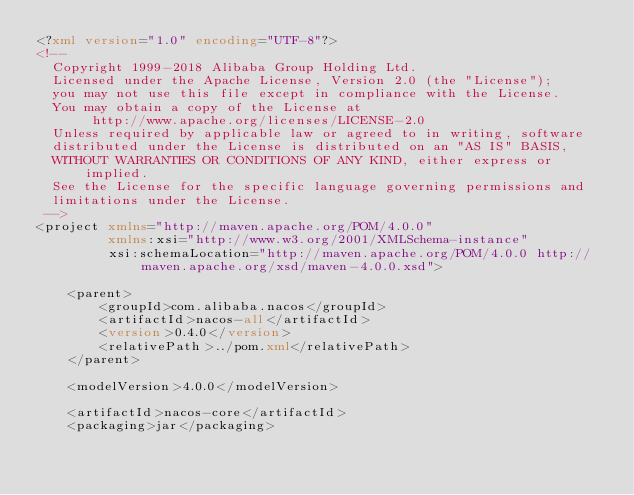Convert code to text. <code><loc_0><loc_0><loc_500><loc_500><_XML_><?xml version="1.0" encoding="UTF-8"?>
<!--
  Copyright 1999-2018 Alibaba Group Holding Ltd.
  Licensed under the Apache License, Version 2.0 (the "License");
  you may not use this file except in compliance with the License.
  You may obtain a copy of the License at
       http://www.apache.org/licenses/LICENSE-2.0
  Unless required by applicable law or agreed to in writing, software
  distributed under the License is distributed on an "AS IS" BASIS,
  WITHOUT WARRANTIES OR CONDITIONS OF ANY KIND, either express or implied.
  See the License for the specific language governing permissions and
  limitations under the License.
 -->
<project xmlns="http://maven.apache.org/POM/4.0.0"
         xmlns:xsi="http://www.w3.org/2001/XMLSchema-instance"
         xsi:schemaLocation="http://maven.apache.org/POM/4.0.0 http://maven.apache.org/xsd/maven-4.0.0.xsd">

    <parent>
        <groupId>com.alibaba.nacos</groupId>
        <artifactId>nacos-all</artifactId>
        <version>0.4.0</version>
        <relativePath>../pom.xml</relativePath>
    </parent>

    <modelVersion>4.0.0</modelVersion>

    <artifactId>nacos-core</artifactId>
    <packaging>jar</packaging>
</code> 